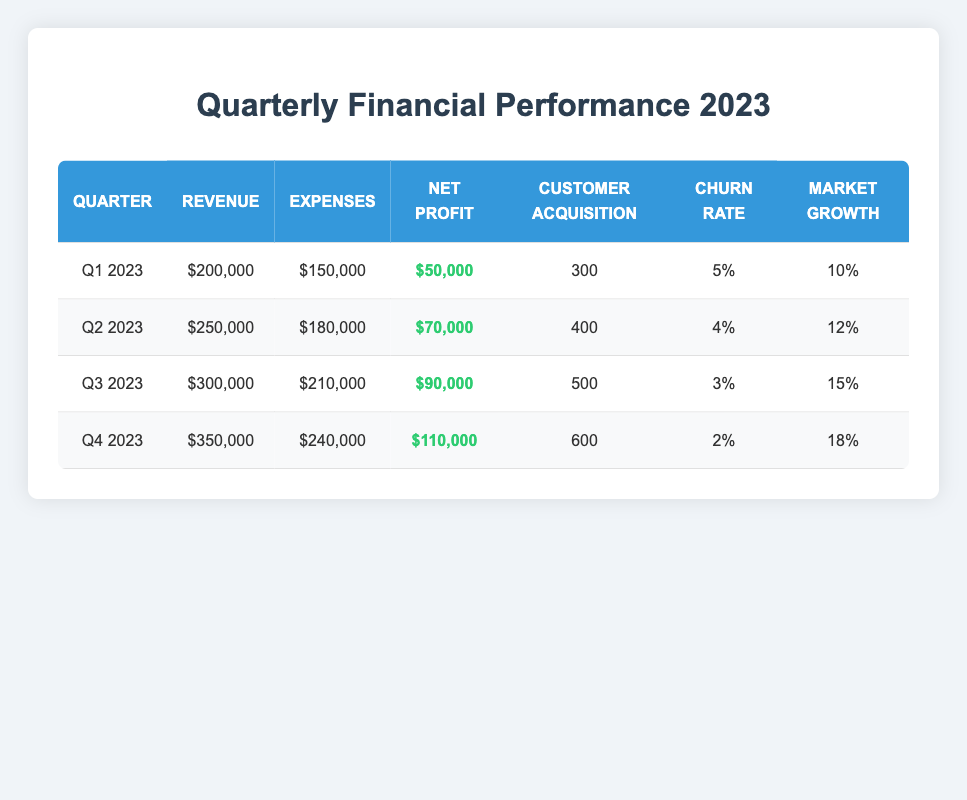What was the net profit in Q3 2023? The net profit for Q3 2023 can be found directly in the table under the "Net Profit" column for that quarter. It shows 90,000.
Answer: 90,000 What were the total expenses for the entire year 2023? To find the total expenses for the year, we sum the expenses from all four quarters: 150,000 (Q1) + 180,000 (Q2) + 210,000 (Q3) + 240,000 (Q4) = 780,000.
Answer: 780,000 Was the customer acquisition rate higher in Q2 2023 than in Q1 2023? In Q1 2023, the customer acquisition was 300, while in Q2 2023, it was 400. Since 400 > 300, the statement is true.
Answer: Yes What is the average churn rate for 2023? To calculate the average churn rate, add the churn rates for all four quarters (5 + 4 + 3 + 2 = 14), then divide by 4 (the number of quarters): 14 / 4 = 3.5.
Answer: 3.5 In which quarter did the startup achieve the highest revenue? The highest revenue is recorded in Q4 2023 with a revenue of 350,000, which is higher than the other quarters listed.
Answer: Q4 2023 How much did the net profit grow from Q1 2023 to Q4 2023? The net profit in Q1 2023 is 50,000 and in Q4 2023 it is 110,000. To find the growth, we subtract Q1 from Q4: 110,000 - 50,000 = 60,000.
Answer: 60,000 Did the market growth percentage increase every quarter in 2023? By reviewing the market growth percentages: 10 (Q1), 12 (Q2), 15 (Q3), and 18 (Q4). Since each subsequent quarter shows a higher percentage than the previous one, the answer is yes.
Answer: Yes What is the total number of customers acquired by the end of Q3 2023? To find the total customers acquired by the end of Q3 2023, we total customer acquisitions from Q1 to Q3: 300 (Q1) + 400 (Q2) + 500 (Q3) = 1,200.
Answer: 1,200 